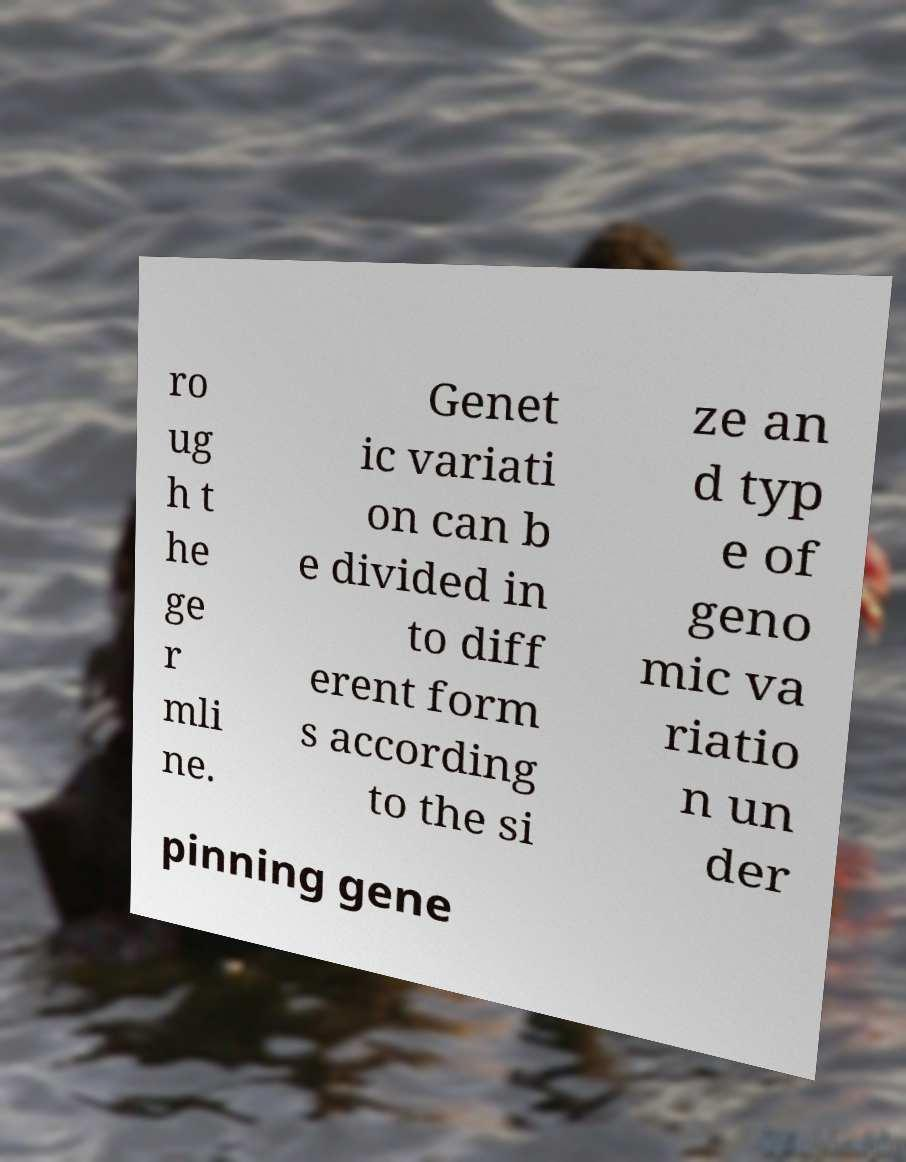Can you read and provide the text displayed in the image?This photo seems to have some interesting text. Can you extract and type it out for me? ro ug h t he ge r mli ne. Genet ic variati on can b e divided in to diff erent form s according to the si ze an d typ e of geno mic va riatio n un der pinning gene 